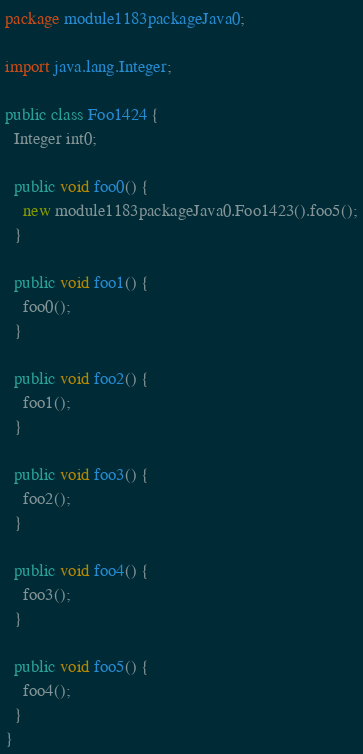<code> <loc_0><loc_0><loc_500><loc_500><_Java_>package module1183packageJava0;

import java.lang.Integer;

public class Foo1424 {
  Integer int0;

  public void foo0() {
    new module1183packageJava0.Foo1423().foo5();
  }

  public void foo1() {
    foo0();
  }

  public void foo2() {
    foo1();
  }

  public void foo3() {
    foo2();
  }

  public void foo4() {
    foo3();
  }

  public void foo5() {
    foo4();
  }
}
</code> 